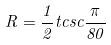<formula> <loc_0><loc_0><loc_500><loc_500>R = \frac { 1 } { 2 } t c s c \frac { \pi } { 8 0 }</formula> 